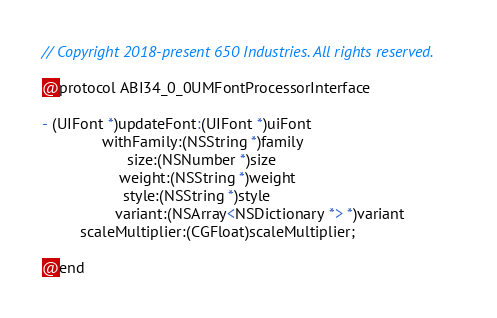<code> <loc_0><loc_0><loc_500><loc_500><_C_>// Copyright 2018-present 650 Industries. All rights reserved.

@protocol ABI34_0_0UMFontProcessorInterface

- (UIFont *)updateFont:(UIFont *)uiFont
              withFamily:(NSString *)family
                    size:(NSNumber *)size
                  weight:(NSString *)weight
                   style:(NSString *)style
                 variant:(NSArray<NSDictionary *> *)variant
         scaleMultiplier:(CGFloat)scaleMultiplier;

@end
</code> 